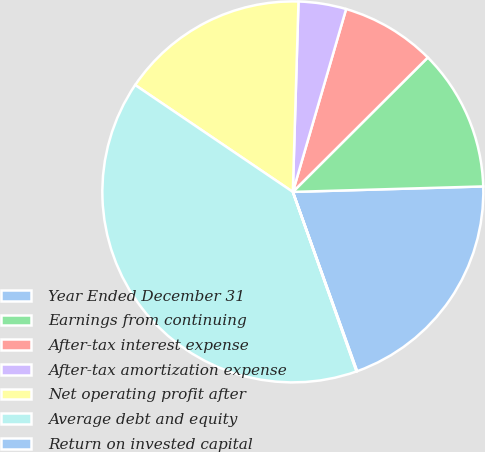<chart> <loc_0><loc_0><loc_500><loc_500><pie_chart><fcel>Year Ended December 31<fcel>Earnings from continuing<fcel>After-tax interest expense<fcel>After-tax amortization expense<fcel>Net operating profit after<fcel>Average debt and equity<fcel>Return on invested capital<nl><fcel>19.98%<fcel>12.01%<fcel>8.02%<fcel>4.04%<fcel>15.99%<fcel>39.91%<fcel>0.05%<nl></chart> 